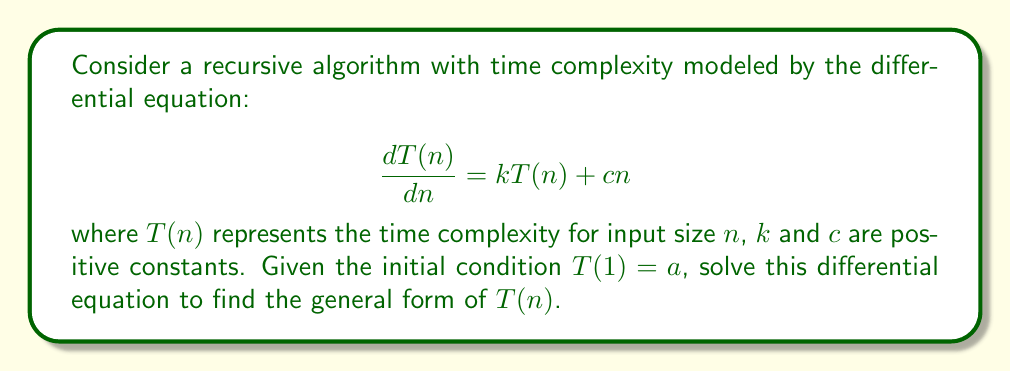Help me with this question. To solve this differential equation, we'll follow these steps:

1) First, recognize that this is a first-order linear differential equation of the form:

   $$\frac{dy}{dx} + P(x)y = Q(x)$$

   where $P(x) = -k$ and $Q(x) = cn$.

2) The integrating factor for this equation is:

   $$\mu(n) = e^{\int P(n) dn} = e^{\int -k dn} = e^{-kn}$$

3) Multiply both sides of the original equation by the integrating factor:

   $$e^{-kn} \frac{dT(n)}{dn} + ke^{-kn}T(n) = cne^{-kn}$$

4) The left side of this equation is the derivative of $e^{-kn}T(n)$:

   $$\frac{d}{dn}(e^{-kn}T(n)) = cne^{-kn}$$

5) Integrate both sides:

   $$e^{-kn}T(n) = \int cne^{-kn} dn$$

6) Solve the integral on the right side using integration by parts:

   $$\int cne^{-kn} dn = -\frac{cn}{k}e^{-kn} - \frac{c}{k^2}e^{-kn} + C$$

7) Substitute this back into the equation:

   $$e^{-kn}T(n) = -\frac{cn}{k}e^{-kn} - \frac{c}{k^2}e^{-kn} + C$$

8) Solve for $T(n)$:

   $$T(n) = -\frac{cn}{k} - \frac{c}{k^2} + Ce^{kn}$$

9) Use the initial condition $T(1) = a$ to find $C$:

   $$a = -\frac{c}{k} - \frac{c}{k^2} + Ce^k$$
   $$C = (a + \frac{c}{k} + \frac{c}{k^2})e^{-k}$$

10) Substitute this value of $C$ back into the general solution:

    $$T(n) = -\frac{cn}{k} - \frac{c}{k^2} + (a + \frac{c}{k} + \frac{c}{k^2})e^{k(n-1)}$$

This is the general solution for the time complexity $T(n)$.
Answer: $$T(n) = -\frac{cn}{k} - \frac{c}{k^2} + (a + \frac{c}{k} + \frac{c}{k^2})e^{k(n-1)}$$ 